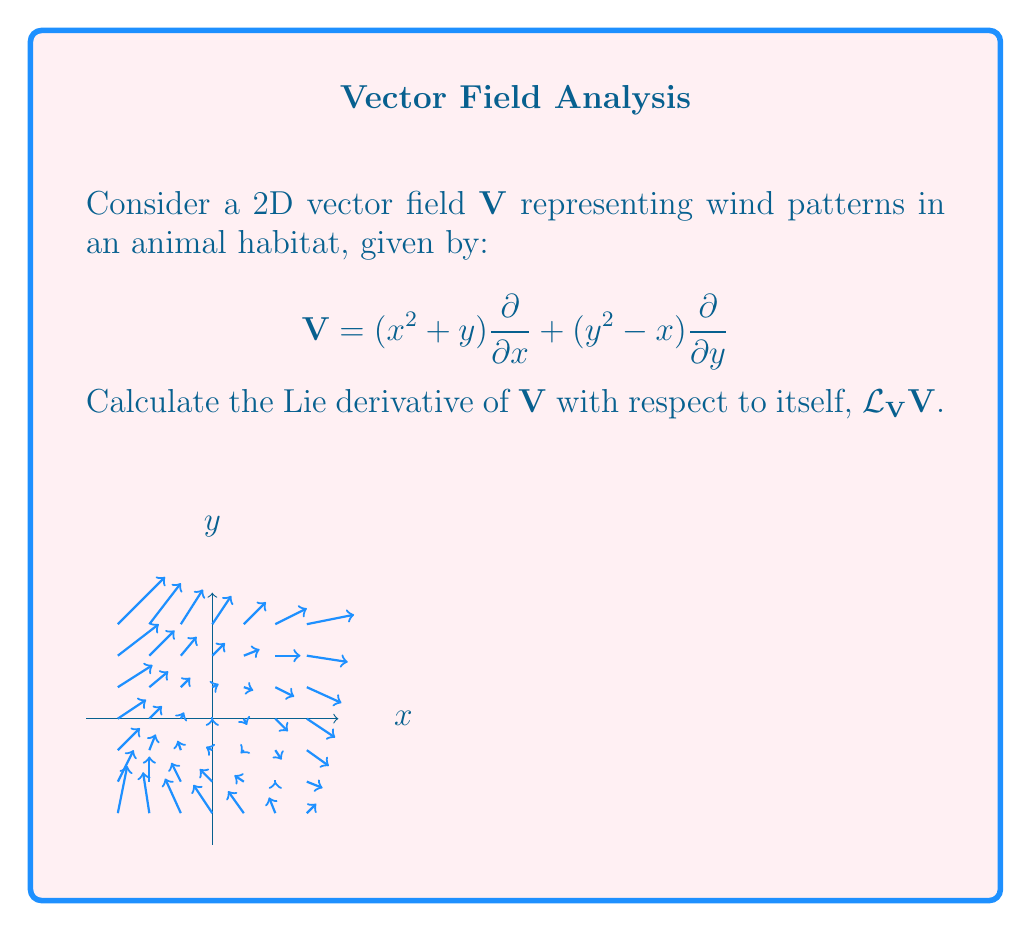Show me your answer to this math problem. To calculate the Lie derivative of $V$ with respect to itself, we follow these steps:

1) The Lie derivative of a vector field $V$ with respect to itself is given by the Lie bracket $[V,V]$, which is always zero. However, let's calculate it explicitly to demonstrate the process.

2) For two vector fields $X = f_1\frac{\partial}{\partial x} + f_2\frac{\partial}{\partial y}$ and $Y = g_1\frac{\partial}{\partial x} + g_2\frac{\partial}{\partial y}$, the Lie bracket is:

   $$[X,Y] = \left(f_1\frac{\partial g_1}{\partial x} + f_2\frac{\partial g_1}{\partial y} - g_1\frac{\partial f_1}{\partial x} - g_2\frac{\partial f_1}{\partial y}\right)\frac{\partial}{\partial x} + \left(f_1\frac{\partial g_2}{\partial x} + f_2\frac{\partial g_2}{\partial y} - g_1\frac{\partial f_2}{\partial x} - g_2\frac{\partial f_2}{\partial y}\right)\frac{\partial}{\partial y}$$

3) In our case, $V = V$, so $f_1 = g_1 = x^2 + y$ and $f_2 = g_2 = y^2 - x$

4) Let's calculate each term:
   
   $\frac{\partial f_1}{\partial x} = \frac{\partial (x^2 + y)}{\partial x} = 2x$
   
   $\frac{\partial f_1}{\partial y} = \frac{\partial (x^2 + y)}{\partial y} = 1$
   
   $\frac{\partial f_2}{\partial x} = \frac{\partial (y^2 - x)}{\partial x} = -1$
   
   $\frac{\partial f_2}{\partial y} = \frac{\partial (y^2 - x)}{\partial y} = 2y$

5) Now, let's substitute these into the Lie bracket formula:

   $$\begin{align*}
   [V,V] &= \left((x^2+y)(2x) + (y^2-x)(1) - (x^2+y)(2x) - (y^2-x)(1)\right)\frac{\partial}{\partial x} \\
   &+ \left((x^2+y)(-1) + (y^2-x)(2y) - (x^2+y)(-1) - (y^2-x)(2y)\right)\frac{\partial}{\partial y}
   \end{align*}$$

6) Simplifying:

   $$[V,V] = (0)\frac{\partial}{\partial x} + (0)\frac{\partial}{\partial y} = 0$$

Therefore, the Lie derivative $\mathcal{L}_V V = [V,V] = 0$.
Answer: $\mathcal{L}_V V = 0$ 